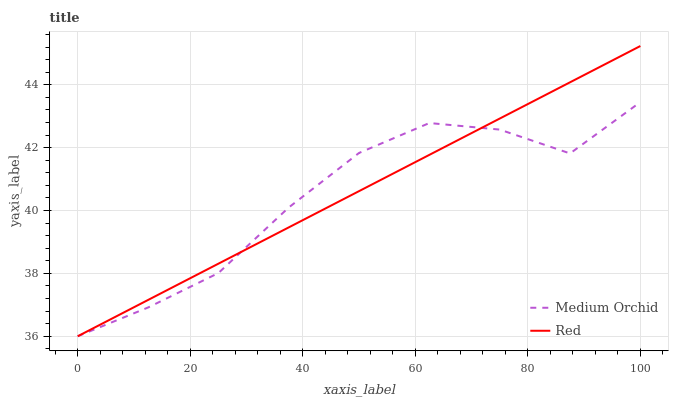Does Medium Orchid have the minimum area under the curve?
Answer yes or no. Yes. Does Red have the maximum area under the curve?
Answer yes or no. Yes. Does Red have the minimum area under the curve?
Answer yes or no. No. Is Red the smoothest?
Answer yes or no. Yes. Is Medium Orchid the roughest?
Answer yes or no. Yes. Is Red the roughest?
Answer yes or no. No. Does Medium Orchid have the lowest value?
Answer yes or no. Yes. Does Red have the highest value?
Answer yes or no. Yes. Does Medium Orchid intersect Red?
Answer yes or no. Yes. Is Medium Orchid less than Red?
Answer yes or no. No. Is Medium Orchid greater than Red?
Answer yes or no. No. 